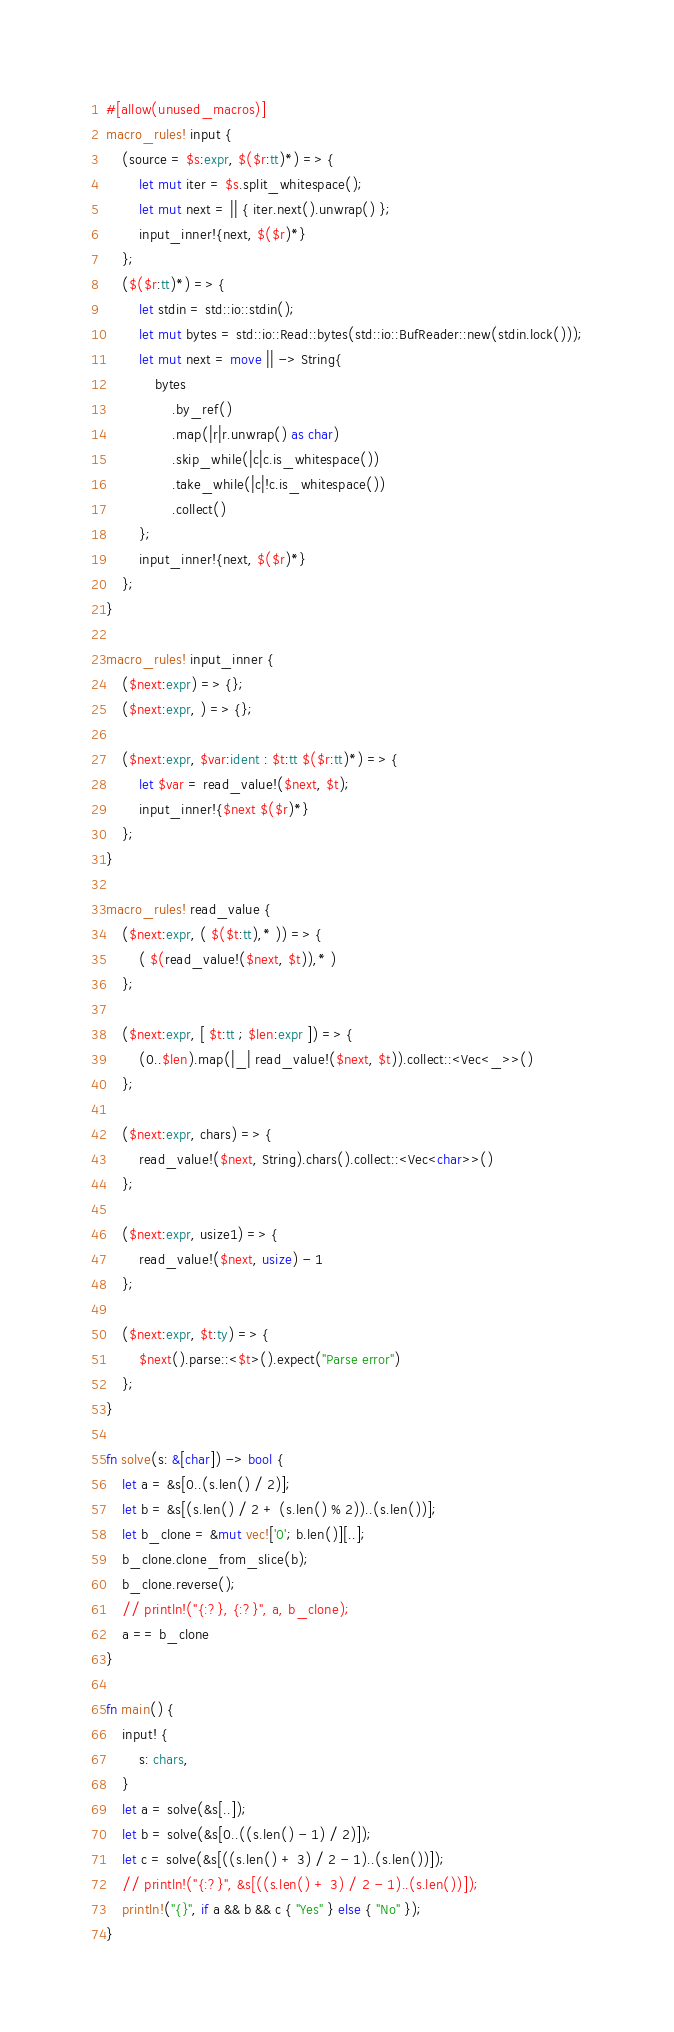Convert code to text. <code><loc_0><loc_0><loc_500><loc_500><_Rust_>#[allow(unused_macros)]
macro_rules! input {
    (source = $s:expr, $($r:tt)*) => {
        let mut iter = $s.split_whitespace();
        let mut next = || { iter.next().unwrap() };
        input_inner!{next, $($r)*}
    };
    ($($r:tt)*) => {
        let stdin = std::io::stdin();
        let mut bytes = std::io::Read::bytes(std::io::BufReader::new(stdin.lock()));
        let mut next = move || -> String{
            bytes
                .by_ref()
                .map(|r|r.unwrap() as char)
                .skip_while(|c|c.is_whitespace())
                .take_while(|c|!c.is_whitespace())
                .collect()
        };
        input_inner!{next, $($r)*}
    };
}

macro_rules! input_inner {
    ($next:expr) => {};
    ($next:expr, ) => {};

    ($next:expr, $var:ident : $t:tt $($r:tt)*) => {
        let $var = read_value!($next, $t);
        input_inner!{$next $($r)*}
    };
}

macro_rules! read_value {
    ($next:expr, ( $($t:tt),* )) => {
        ( $(read_value!($next, $t)),* )
    };

    ($next:expr, [ $t:tt ; $len:expr ]) => {
        (0..$len).map(|_| read_value!($next, $t)).collect::<Vec<_>>()
    };

    ($next:expr, chars) => {
        read_value!($next, String).chars().collect::<Vec<char>>()
    };

    ($next:expr, usize1) => {
        read_value!($next, usize) - 1
    };

    ($next:expr, $t:ty) => {
        $next().parse::<$t>().expect("Parse error")
    };
}

fn solve(s: &[char]) -> bool {
    let a = &s[0..(s.len() / 2)];
    let b = &s[(s.len() / 2 + (s.len() % 2))..(s.len())];
    let b_clone = &mut vec!['0'; b.len()][..];
    b_clone.clone_from_slice(b);
    b_clone.reverse();
    // println!("{:?}, {:?}", a, b_clone);
    a == b_clone
}

fn main() {
    input! {
        s: chars,
    }
    let a = solve(&s[..]);
    let b = solve(&s[0..((s.len() - 1) / 2)]);
    let c = solve(&s[((s.len() + 3) / 2 - 1)..(s.len())]);
    // println!("{:?}", &s[((s.len() + 3) / 2 - 1)..(s.len())]);
    println!("{}", if a && b && c { "Yes" } else { "No" });
}
</code> 